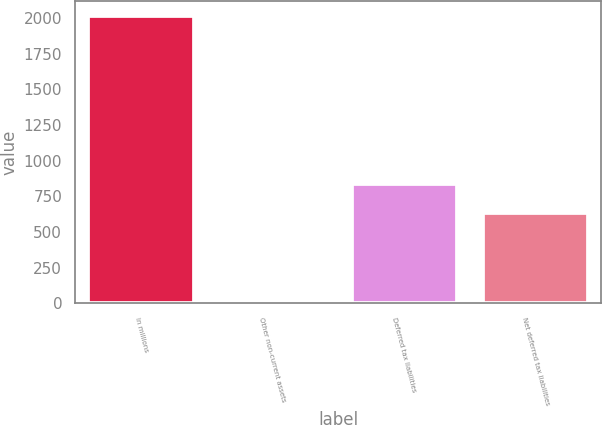<chart> <loc_0><loc_0><loc_500><loc_500><bar_chart><fcel>In millions<fcel>Other non-current assets<fcel>Deferred tax liabilities<fcel>Net deferred tax liabilities<nl><fcel>2015<fcel>2.2<fcel>834.88<fcel>633.6<nl></chart> 